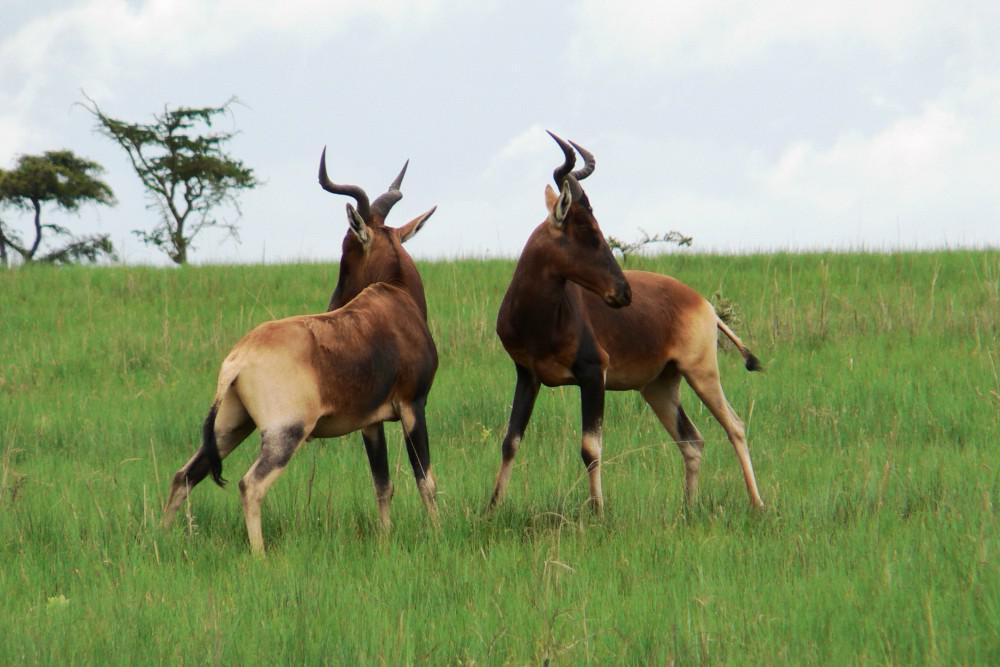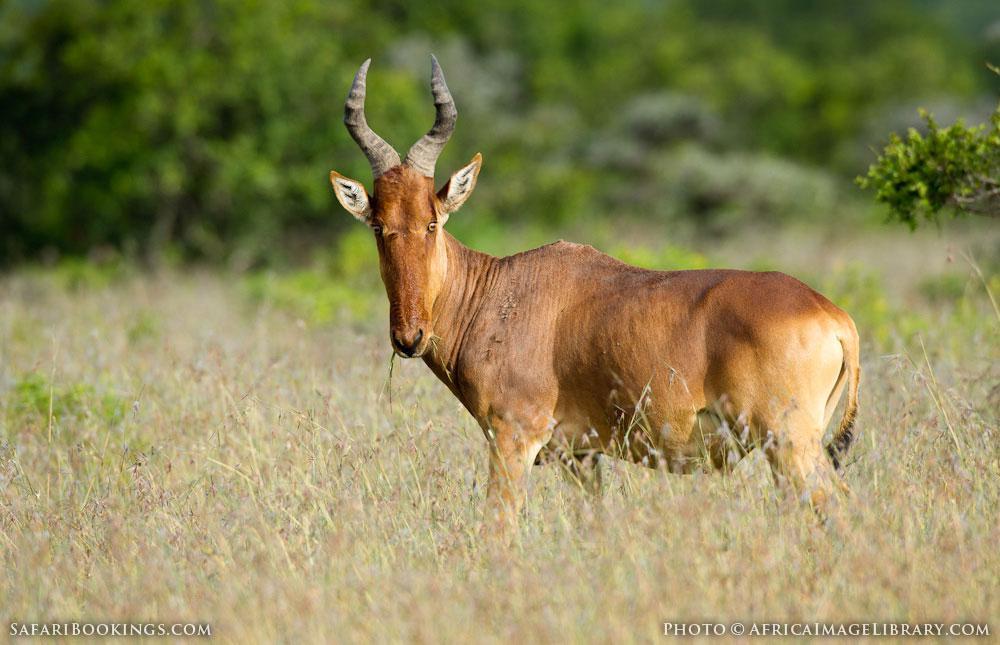The first image is the image on the left, the second image is the image on the right. Considering the images on both sides, is "There are 3 animals." valid? Answer yes or no. Yes. 